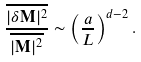Convert formula to latex. <formula><loc_0><loc_0><loc_500><loc_500>\frac { \overline { | \delta \mathbf M | ^ { 2 } } } { \overline { | \mathbf M | ^ { 2 } } } \sim \left ( \frac { a } { L } \right ) ^ { d - 2 } .</formula> 